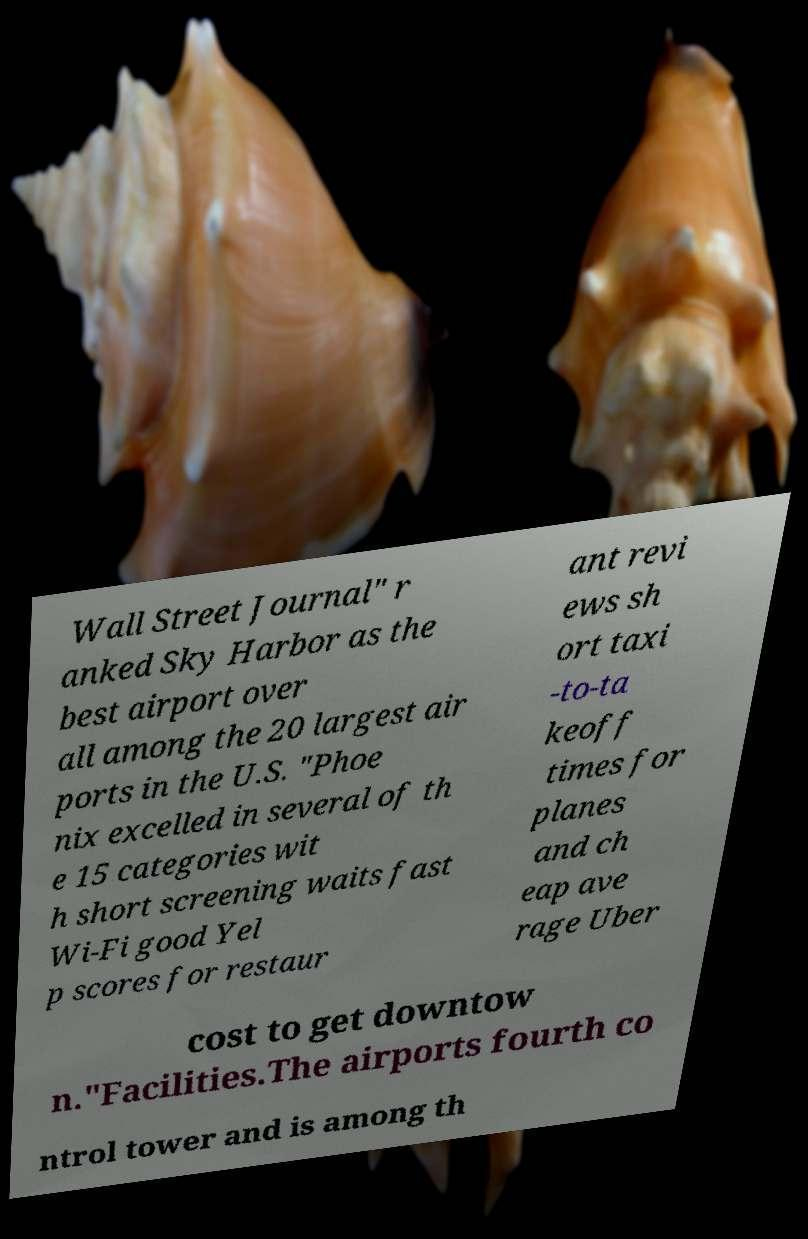I need the written content from this picture converted into text. Can you do that? Wall Street Journal" r anked Sky Harbor as the best airport over all among the 20 largest air ports in the U.S. "Phoe nix excelled in several of th e 15 categories wit h short screening waits fast Wi-Fi good Yel p scores for restaur ant revi ews sh ort taxi -to-ta keoff times for planes and ch eap ave rage Uber cost to get downtow n."Facilities.The airports fourth co ntrol tower and is among th 